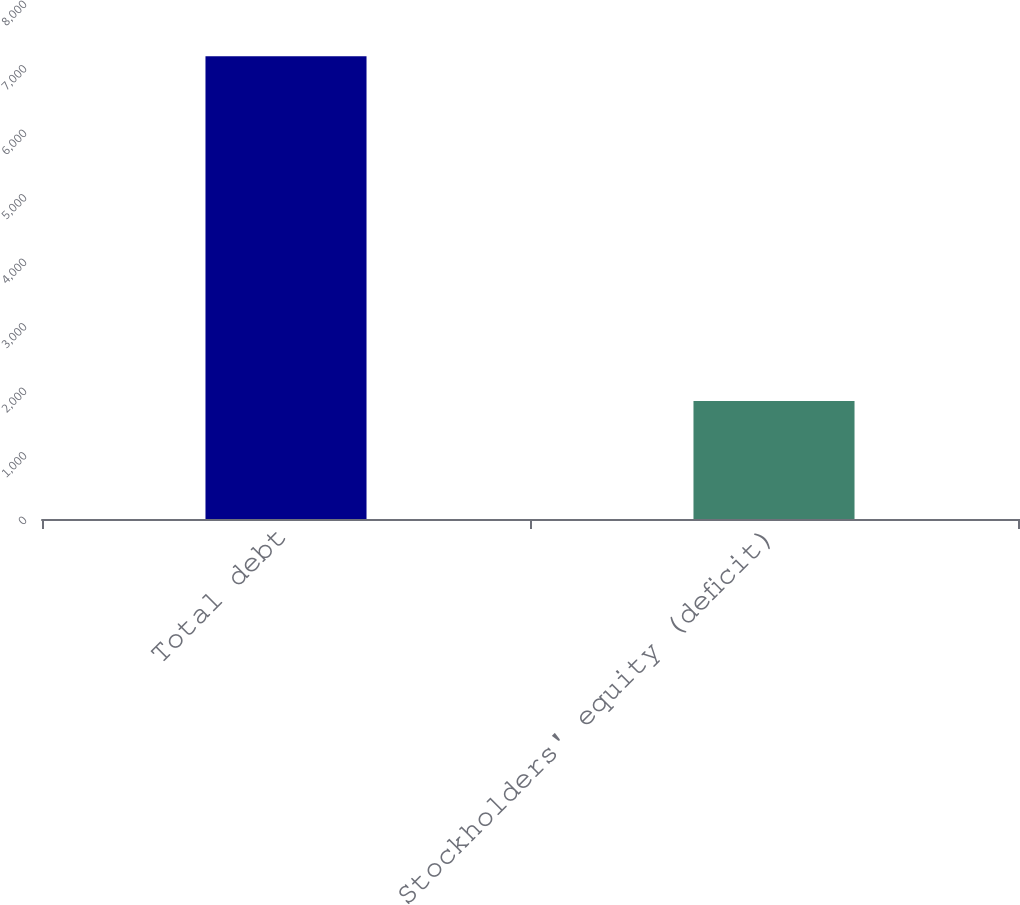Convert chart to OTSL. <chart><loc_0><loc_0><loc_500><loc_500><bar_chart><fcel>Total debt<fcel>Stockholders' equity (deficit)<nl><fcel>7173<fcel>1828<nl></chart> 